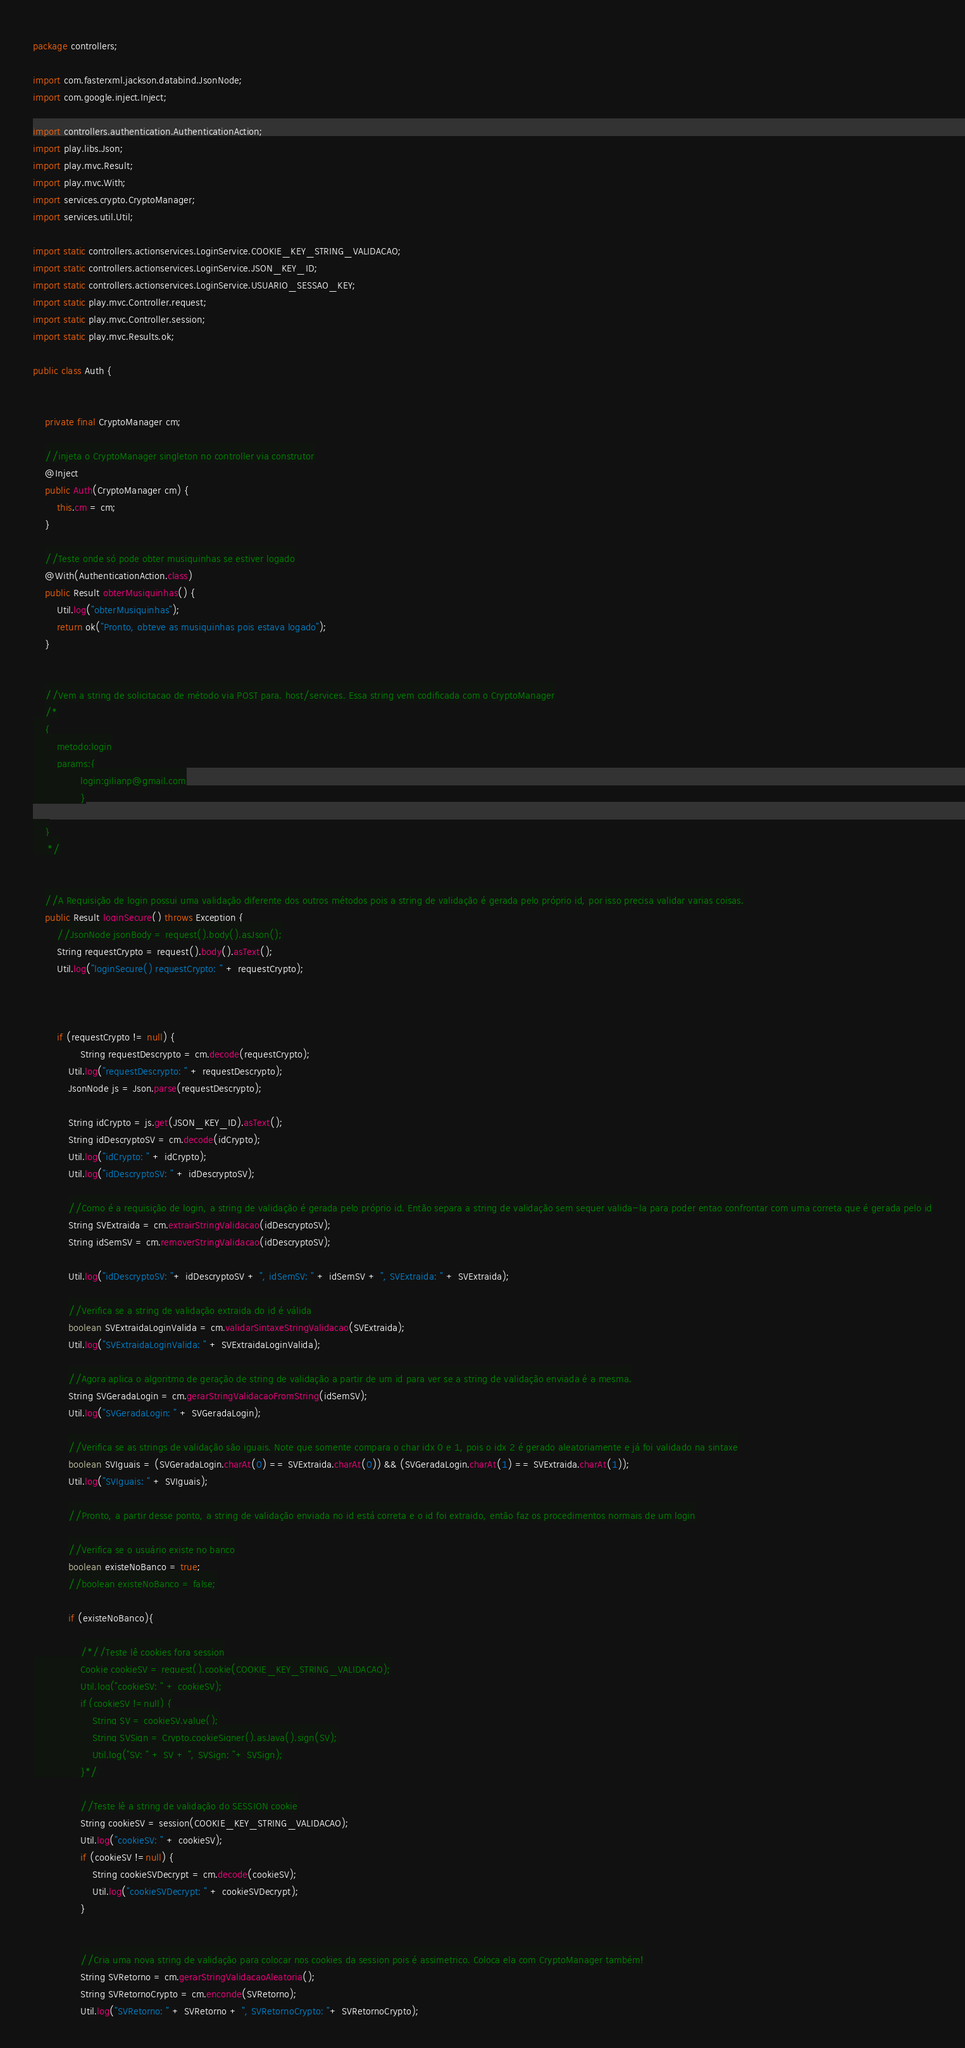<code> <loc_0><loc_0><loc_500><loc_500><_Java_>package controllers;

import com.fasterxml.jackson.databind.JsonNode;
import com.google.inject.Inject;

import controllers.authentication.AuthenticationAction;
import play.libs.Json;
import play.mvc.Result;
import play.mvc.With;
import services.crypto.CryptoManager;
import services.util.Util;

import static controllers.actionservices.LoginService.COOKIE_KEY_STRING_VALIDACAO;
import static controllers.actionservices.LoginService.JSON_KEY_ID;
import static controllers.actionservices.LoginService.USUARIO_SESSAO_KEY;
import static play.mvc.Controller.request;
import static play.mvc.Controller.session;
import static play.mvc.Results.ok;

public class Auth {


    private final CryptoManager cm;

    //injeta o CryptoManager singleton no controller via construtor
    @Inject
    public Auth(CryptoManager cm) {
        this.cm = cm;
    }

    //Teste onde só pode obter musiquinhas se estiver logado
    @With(AuthenticationAction.class)
    public Result obterMusiquinhas() {
        Util.log("obterMusiquinhas");
        return ok("Pronto, obteve as musiquinhas pois estava logado");
    }


    //Vem a string de solicitacao de método via POST para. host/services. Essa string vem codificada com o CryptoManager
    /*
    {
        metodo:login
        params:{
                login:gilianp@gmail.com
                }

    }
     */


    //A Requisição de login possui uma validação diferente dos outros métodos pois a string de validação é gerada pelo próprio id, por isso precisa validar varias coisas.
    public Result loginSecure() throws Exception {
        //JsonNode jsonBody = request().body().asJson();
        String requestCrypto = request().body().asText();
        Util.log("loginSecure() requestCrypto: " + requestCrypto);



        if (requestCrypto != null) {
                String requestDescrypto = cm.decode(requestCrypto);
            Util.log("requestDescrypto: " + requestDescrypto);
            JsonNode js = Json.parse(requestDescrypto);

            String idCrypto = js.get(JSON_KEY_ID).asText();
            String idDescryptoSV = cm.decode(idCrypto);
            Util.log("idCrypto: " + idCrypto);
            Util.log("idDescryptoSV: " + idDescryptoSV);

            //Como é a requisição de login, a string de validação é gerada pelo próprio id. Então separa a string de validação sem sequer valida-la para poder entao confrontar com uma correta que é gerada pelo id
            String SVExtraida = cm.extrairStringValidacao(idDescryptoSV);
            String idSemSV = cm.removerStringValidacao(idDescryptoSV);

            Util.log("idDescryptoSV: "+ idDescryptoSV + ", idSemSV: " + idSemSV + ", SVExtraida: " + SVExtraida);

            //Verifica se a string de validação extraida do id é válida
            boolean SVExtraidaLoginValida = cm.validarSintaxeStringValidacao(SVExtraida);
            Util.log("SVExtraidaLoginValida: " + SVExtraidaLoginValida);

            //Agora aplica o algoritmo de geração de string de validação a partir de um id para ver se a string de validação enviada é a mesma.
            String SVGeradaLogin = cm.gerarStringValidacaoFromString(idSemSV);
            Util.log("SVGeradaLogin: " + SVGeradaLogin);

            //Verifica se as strings de validação são iguais. Note que somente compara o char idx 0 e 1, pois o idx 2 é gerado aleatoriamente e já foi validado na sintaxe
            boolean SVIguais = (SVGeradaLogin.charAt(0) == SVExtraida.charAt(0)) && (SVGeradaLogin.charAt(1) == SVExtraida.charAt(1));
            Util.log("SVIguais: " + SVIguais);

            //Pronto, a partir desse ponto, a string de validação enviada no id está correta e o id foi extraido, então faz os procedimentos normais de um login

            //Verifica se o usuário existe no banco
            boolean existeNoBanco = true;
            //boolean existeNoBanco = false;

            if (existeNoBanco){

                /*//Teste lê cookies fora session
                Cookie cookieSV = request().cookie(COOKIE_KEY_STRING_VALIDACAO);
                Util.log("cookieSV: " + cookieSV);
                if (cookieSV !=null) {
                    String SV = cookieSV.value();
                    String SVSign = Crypto.cookieSigner().asJava().sign(SV);
                    Util.log("SV: " + SV + ", SVSign: "+ SVSign);
                }*/

                //Teste lê a string de validação do SESSION cookie
                String cookieSV = session(COOKIE_KEY_STRING_VALIDACAO);
                Util.log("cookieSV: " + cookieSV);
                if (cookieSV !=null) {
                    String cookieSVDecrypt = cm.decode(cookieSV);
                    Util.log("cookieSVDecrypt: " + cookieSVDecrypt);
                }


                //Cria uma nova string de validação para colocar nos cookies da session pois é assimetrico. Coloca ela com CryptoManager também!
                String SVRetorno = cm.gerarStringValidacaoAleatoria();
                String SVRetornoCrypto = cm.enconde(SVRetorno);
                Util.log("SVRetorno: " + SVRetorno + ", SVRetornoCrypto: "+ SVRetornoCrypto);</code> 